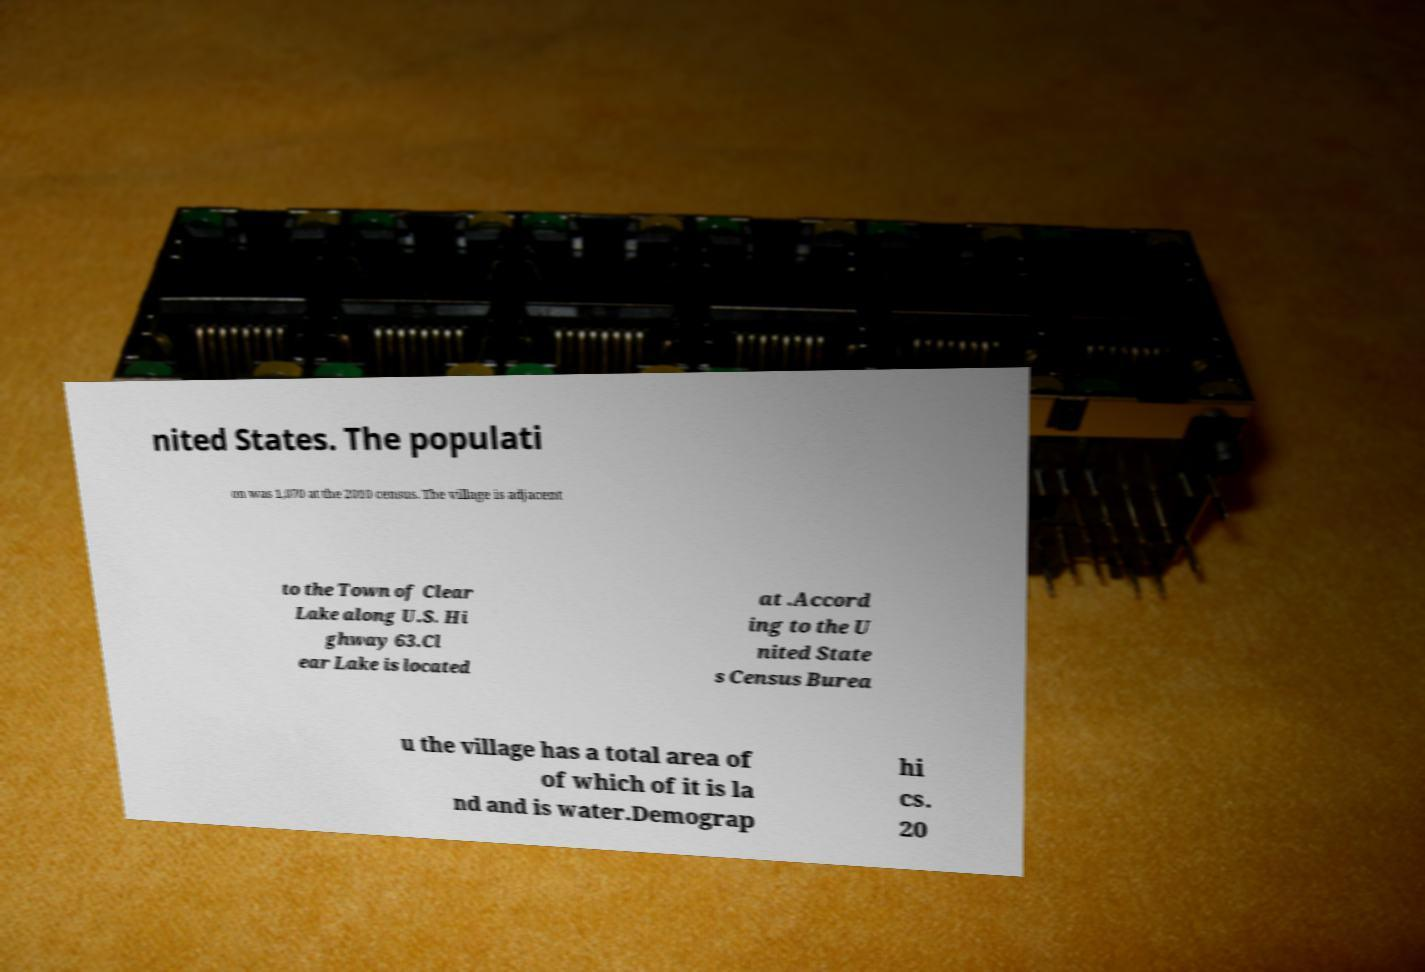Please identify and transcribe the text found in this image. nited States. The populati on was 1,070 at the 2010 census. The village is adjacent to the Town of Clear Lake along U.S. Hi ghway 63.Cl ear Lake is located at .Accord ing to the U nited State s Census Burea u the village has a total area of of which of it is la nd and is water.Demograp hi cs. 20 